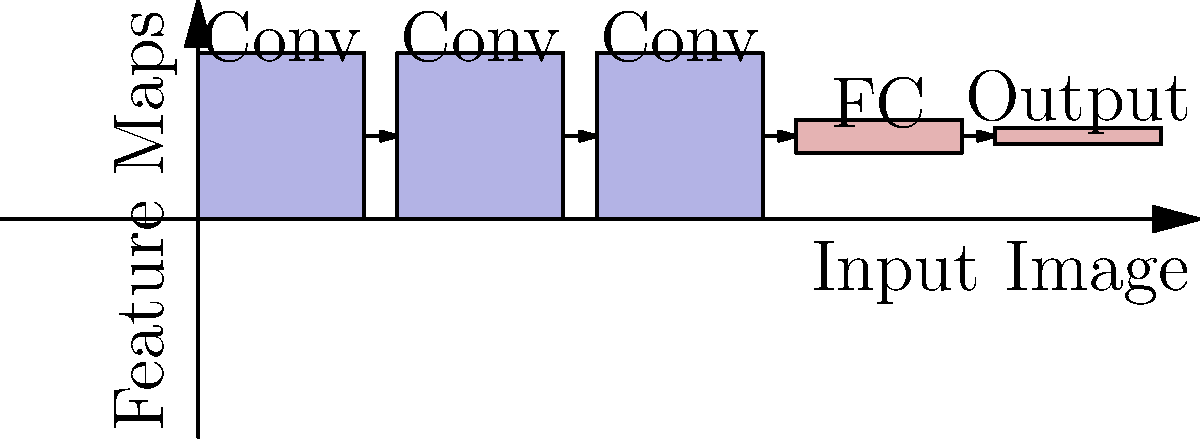In a CNN architecture for signature recognition, what is the primary purpose of the convolutional layers, and how do they contribute to the model's ability to identify unique features in handwritten signatures? 1. Convolutional layers in a CNN are designed to extract features from input images:
   - They apply filters (kernels) across the input image to detect patterns.
   - Each filter learns to recognize specific features (e.g., edges, curves, loops).

2. In signature recognition:
   - Initial layers detect basic features like lines and curves.
   - Deeper layers combine these to recognize more complex patterns specific to signatures.

3. Contribution to feature identification:
   - Convolutional layers maintain spatial relationships between pixels.
   - They use shared weights, reducing parameters and improving generalization.
   - This allows the network to recognize features regardless of their position in the image.

4. Advantage for signature recognition:
   - Signatures vary in size, slant, and precise shape.
   - Convolutional layers can detect key features despite these variations.
   - This makes the model more robust to natural variations in handwriting.

5. Feature maps:
   - Output of each convolutional layer is a set of feature maps.
   - These maps highlight areas of the image where specific features are detected.
   - Deeper in the network, these maps represent increasingly abstract signature characteristics.

6. Pooling layers (often used with convolutions):
   - Reduce the spatial dimensions of the feature maps.
   - This makes the network more invariant to small shifts and distortions.

The convolutional layers thus form a hierarchy of feature detectors, progressing from simple to complex, enabling the CNN to effectively recognize and authenticate signatures based on their unique characteristics.
Answer: Extract hierarchical features invariant to position and small distortions 